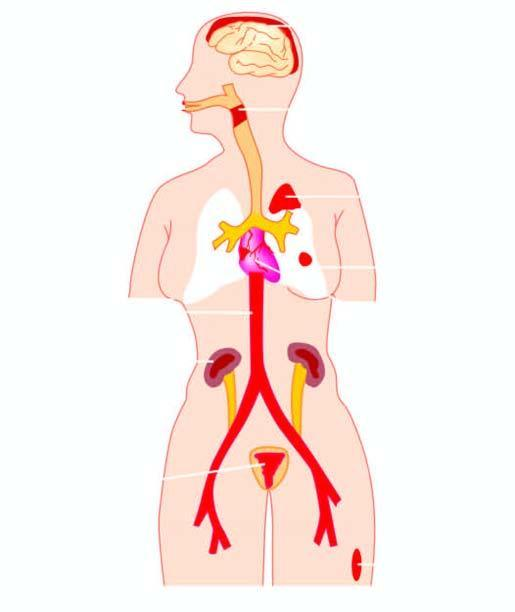s diseases caused by streptococci?
Answer the question using a single word or phrase. Yes 